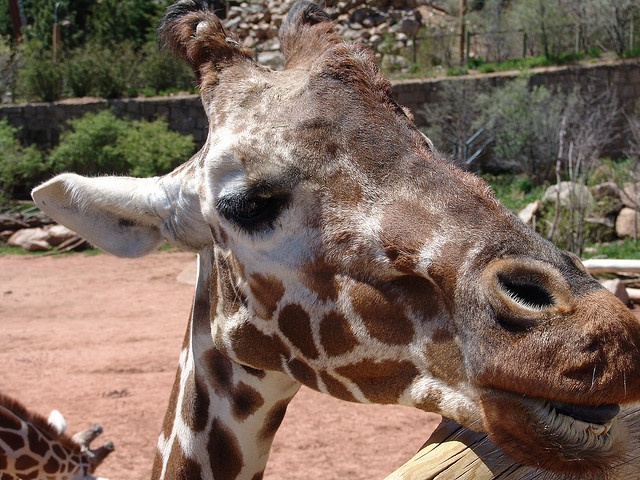Describe the objects in this image and their specific colors. I can see a giraffe in black, gray, and maroon tones in this image. 